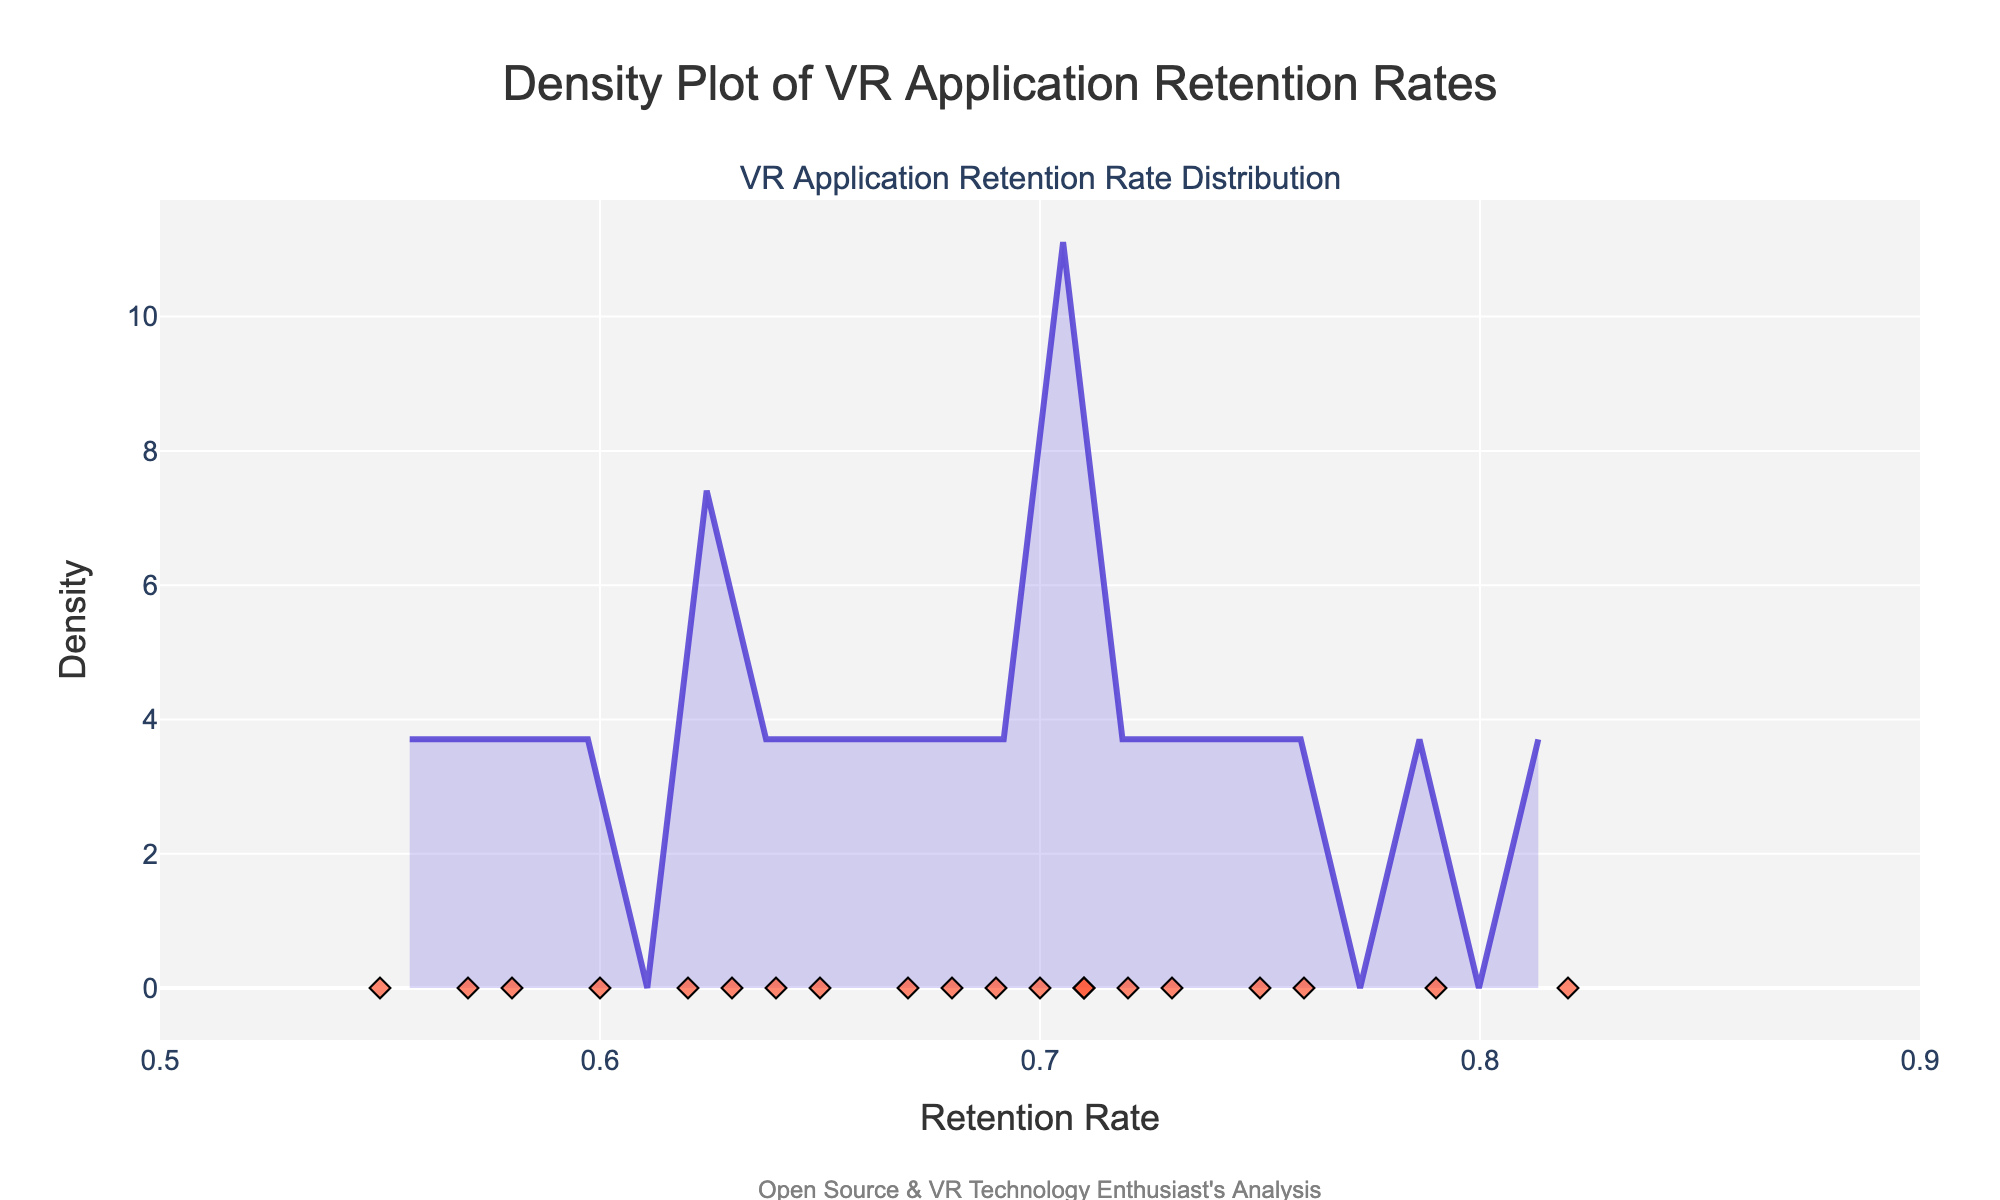What is the title of the figure? The title is usually at the top center of the figure. It says "Density Plot of VR Application Retention Rates" in this plot.
Answer: Density Plot of VR Application Retention Rates What is the highest retention rate observed among the listed VR applications? By looking at the x-axis, the highest retention rate is aligned with the individual data points, where one dot represents 0.82.
Answer: 0.82 Which VR application has the highest retention rate? By inspecting the individual markers on the plot, the highest retention rate (0.82) is associated with the application Beat Saber in the tooltips.
Answer: Beat Saber How many VR applications have a retention rate above 0.7? By examining the scatter points to the right of the 0.7 mark on the x-axis, seven points are observed above 0.7.
Answer: 7 What is the x-axis representing? The x-axis label indicates it is measuring "Retention Rate".
Answer: Retention Rate Which application has the lowest retention rate? Referring to the tooltip on the scatter points, the leftmost point (0.55) corresponds to Google Cardboard.
Answer: Google Cardboard What is the density value at a retention rate of 0.76? From the density plot, trace vertically from 0.76 on the x-axis to the density curve. The highest point intersects slightly below 2 on the y-axis, around 1.5.
Answer: ~1.5 What color is used for the density curve in the plot? The density curve is described to be in a shade of purple, which is displayed as "purple" in the natural world of colors.
Answer: Purple What is the average retention rate of all the VR applications? To calculate, sum all the retention rates (add the listed values) and divide by the total number of applications (20). ((0.68 + 0.72 + 0.65 + 0.70 + 0.58 + 0.62 + 0.75 + 0.71 + 0.82 + 0.79 + 0.67 + 0.73 + 0.60 + 0.64 + 0.55 + 0.76 + 0.69 + 0.71 + 0.63 + 0.57) / 20 = 13.17 / 20 = 0.6585.
Answer: 0.66 Which applications have a retention rate lower than the average? Compare each application's retention rate against the average (0.66). Applications with rates below this are Mozilla Hubs, AltspaceVR, Mozilla Firefox Reality, Open Source VR (OSVR), Job Simulator, Daydream, Google Cardboard.
Answer: Mozilla Hubs, AltspaceVR, Mozilla Firefox Reality, OSVR, Job Simulator, Daydream, Google Cardboard 